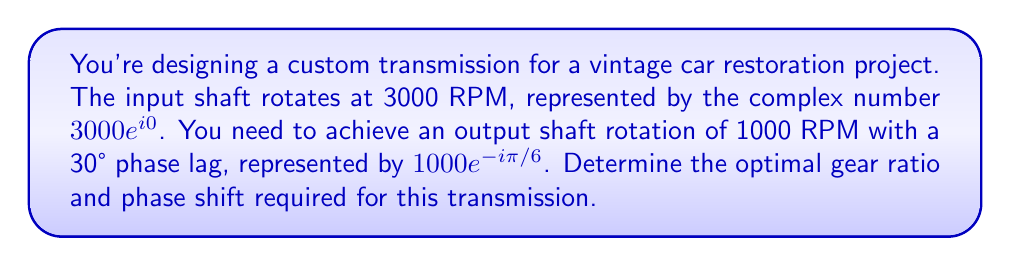What is the answer to this math problem? Let's approach this step-by-step:

1) The input shaft rotation is represented by $z_1 = 3000e^{i0}$
2) The desired output shaft rotation is $z_2 = 1000e^{-i\pi/6}$

3) The gear ratio and phase shift can be represented by a complex number $z$ such that:
   $z_1 \cdot z = z_2$

4) To find $z$, we divide $z_2$ by $z_1$:
   $z = \frac{z_2}{z_1} = \frac{1000e^{-i\pi/6}}{3000e^{i0}}$

5) Simplify:
   $z = \frac{1000}{3000}e^{-i\pi/6} = \frac{1}{3}e^{-i\pi/6}$

6) The magnitude of $z$ gives the gear ratio:
   $|z| = \frac{1}{3}$

7) The argument of $z$ gives the phase shift:
   $\arg(z) = -\frac{\pi}{6} = -30°$

Therefore, the optimal gear ratio is 1:3, and the phase shift is -30°.
Answer: Gear ratio: 1:3, Phase shift: -30° 